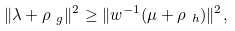Convert formula to latex. <formula><loc_0><loc_0><loc_500><loc_500>\| \lambda + \rho _ { \ g } \| ^ { 2 } \geq \| w ^ { - 1 } ( \mu + \rho _ { \ h } ) \| ^ { 2 } ,</formula> 